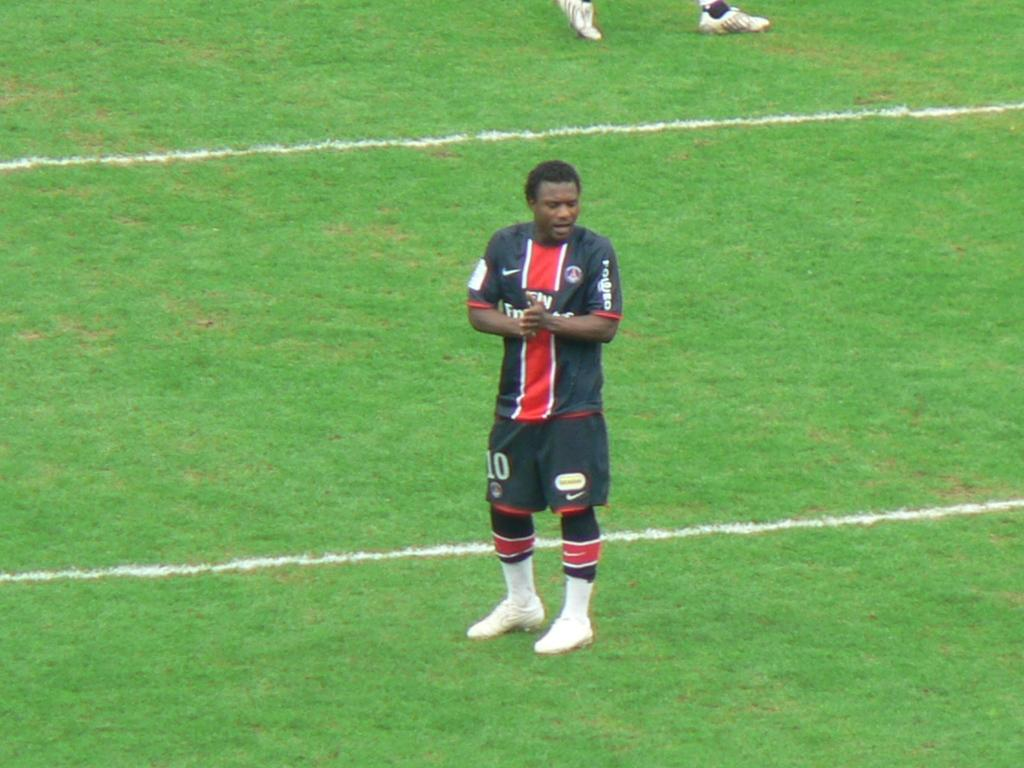<image>
Relay a brief, clear account of the picture shown. Soccer player in black and red uniform with the number 10 in white. 